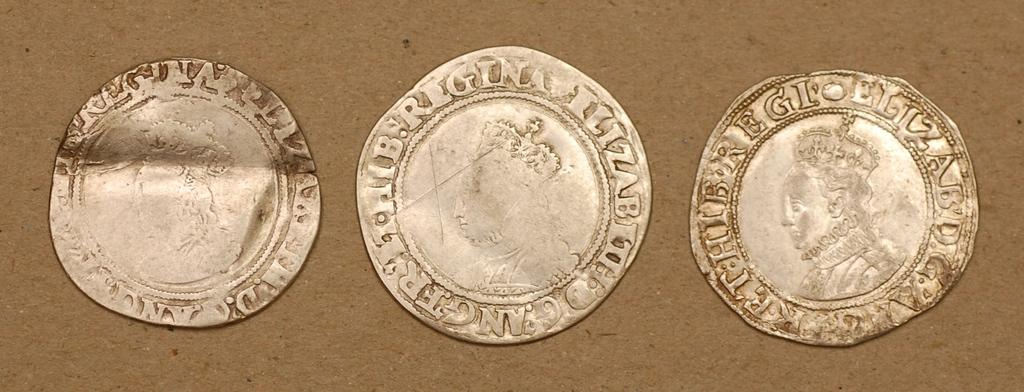What can be seen in the image that represents currency? There are different types of coins in the image. What is depicted on the coins besides the text? There are pictures of persons on the coins. What information is provided on the coins through text? There is text on the coins. How many toes can be seen on the geese in the image? There are no geese present in the image, so the number of toes cannot be determined. 